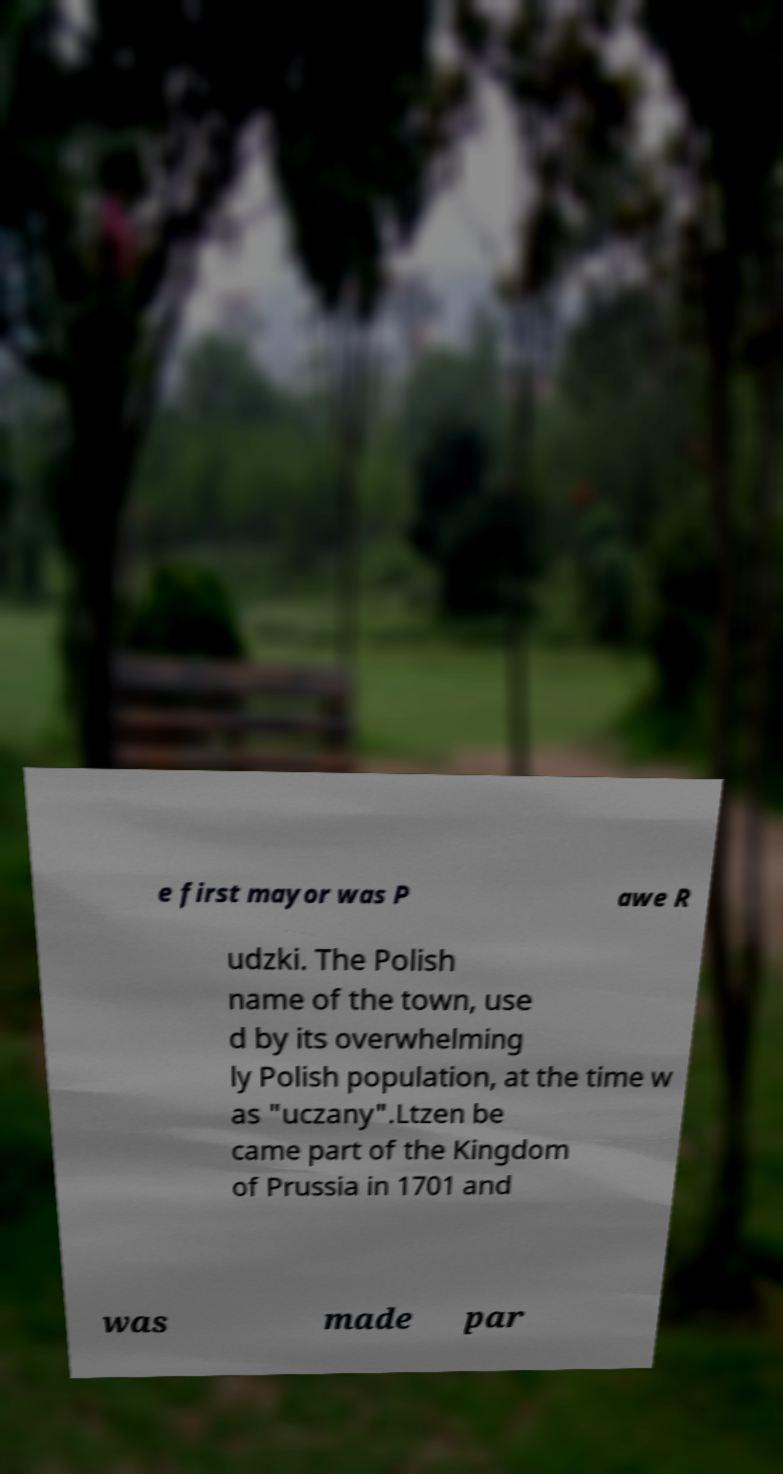Could you extract and type out the text from this image? e first mayor was P awe R udzki. The Polish name of the town, use d by its overwhelming ly Polish population, at the time w as "uczany".Ltzen be came part of the Kingdom of Prussia in 1701 and was made par 